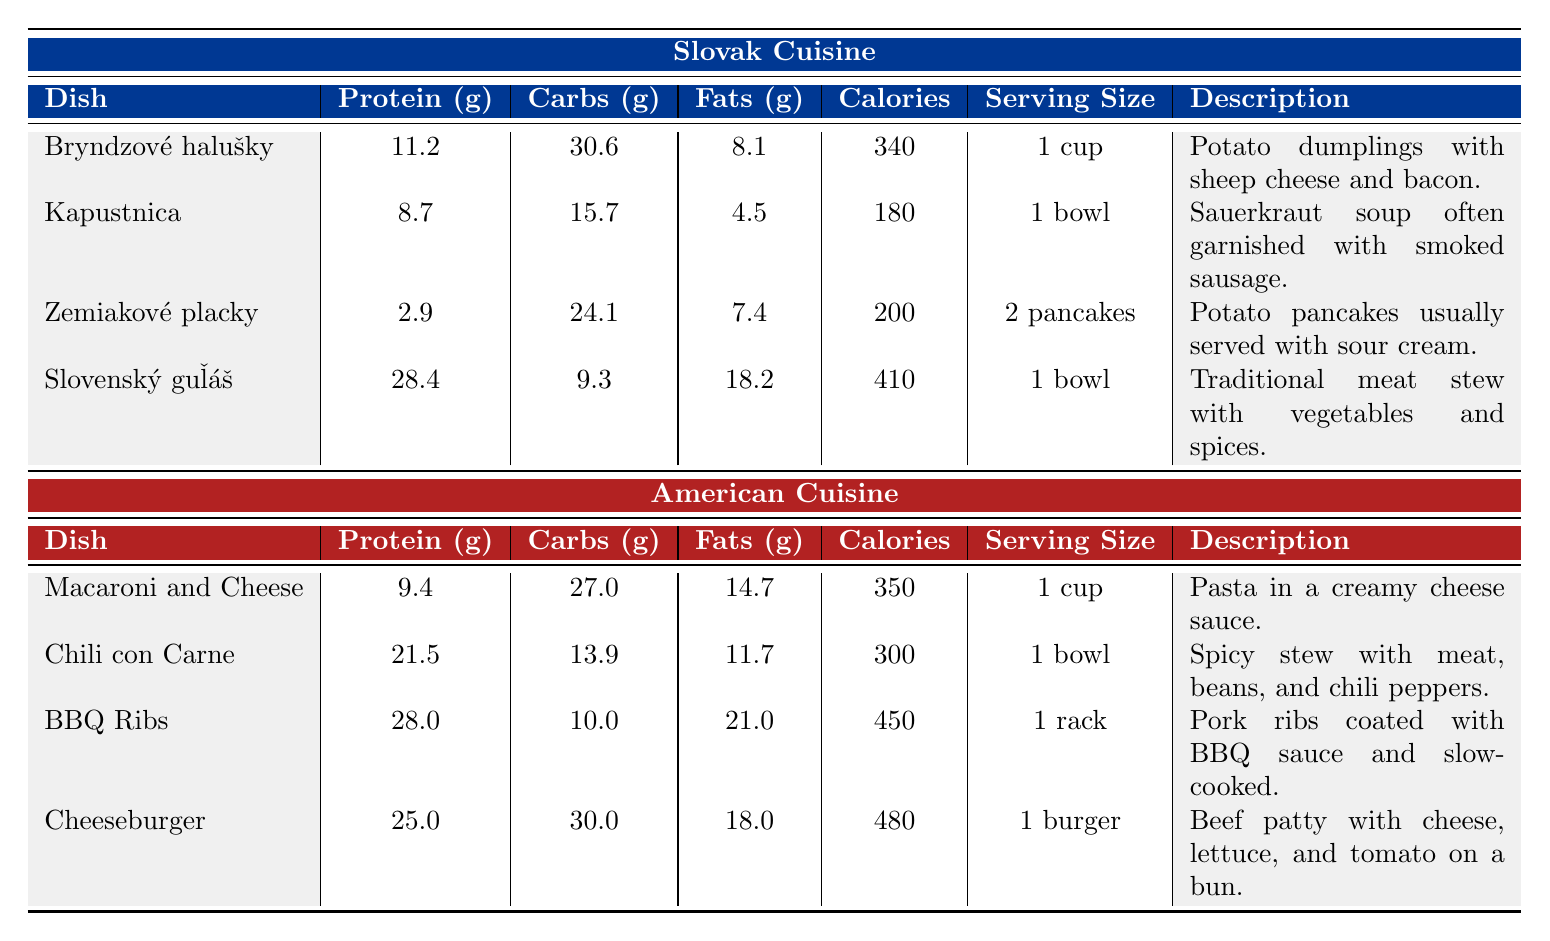What is the highest protein dish in Slovak cuisine? The dishes in Slovak cuisine include Bryndzové halušky (11.2g), Kapustnica (8.7g), Zemiakové placky (2.9g), and Slovenský guľáš (28.4g). The highest protein content is from Slovenský guľáš at 28.4g.
Answer: Slovenský guľáš What is the calorie count of BBQ Ribs? The entry for BBQ Ribs lists its calorie content as 450 calories.
Answer: 450 calories Which dish has the lowest carbohydrate content in American cuisine? In American cuisine, the carbohydrate values are: Macaroni and Cheese (27.0g), Chili con Carne (13.9g), BBQ Ribs (10.0g), and Cheeseburger (30.0g). The lowest carbohydrate content is in BBQ Ribs with 10.0g.
Answer: BBQ Ribs How many calories are in Bryndzové halušky and Macaroni and Cheese combined? The calories for Bryndzové halušky are 340 and for Macaroni and Cheese they are 350. Adding them together gives 340 + 350 = 690 calories.
Answer: 690 calories Is Zemiakové placky higher in protein or fat? Zemiakové placky has 2.9g of protein and 7.4g of fat. Since 7.4g is greater than 2.9g, it indicates that fat content is higher.
Answer: No, fat is higher What is the average calorie count of all dishes listed in Slovak cuisine? The calorie counts in Slovak cuisine are: Bryndzové halušky (340), Kapustnica (180), Zemiakové placky (200), Slovenský guľáš (410). The sum is 340 + 180 + 200 + 410 = 1130. Dividing by the number of dishes (4) gives an average of 1130/4 = 282.5.
Answer: 282.5 What dish has both the highest fat content and highest calorie content among all dishes? The highest fat content is found in BBQ Ribs at 21.0g and the highest calorie content is in Cheeseburger at 480 calories. So, we compare both and find BBQ Ribs (with the highest fat ) and Cheeseburger (with the highest calories).
Answer: BBQ Ribs for fat, Cheeseburger for calories Which cuisine has a dish that combines higher protein and lower carbohydrates overall? Comparing the highest protein and lower carbohydrate dishes, Slovenský guľáš has 28.4g of protein and 9.3g of carbohydrates, while the American cuisine’s Chili con Carne has 21.5g protein and 13.9g carbohydrates. Slovenský guľáš has higher protein (28.4g) and lower carbohydrates (9.3g).
Answer: Slovak cuisine's Slovenský guľáš What is the total fat content of all dishes in American cuisine? The fat content for American dishes is as follows: Macaroni and Cheese (14.7g), Chili con Carne (11.7g), BBQ Ribs (21.0g), and Cheeseburger (18.0g). Summing them gives 14.7 + 11.7 + 21.0 + 18.0 = 65.4g of total fat.
Answer: 65.4g 